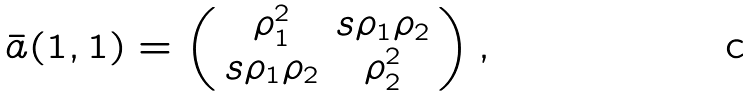Convert formula to latex. <formula><loc_0><loc_0><loc_500><loc_500>\bar { a } ( 1 , 1 ) = \left ( \begin{array} { c c } \rho _ { 1 } ^ { 2 } & s \rho _ { 1 } \rho _ { 2 } \\ s \rho _ { 1 } \rho _ { 2 } & \rho _ { 2 } ^ { 2 } \end{array} \right ) ,</formula> 